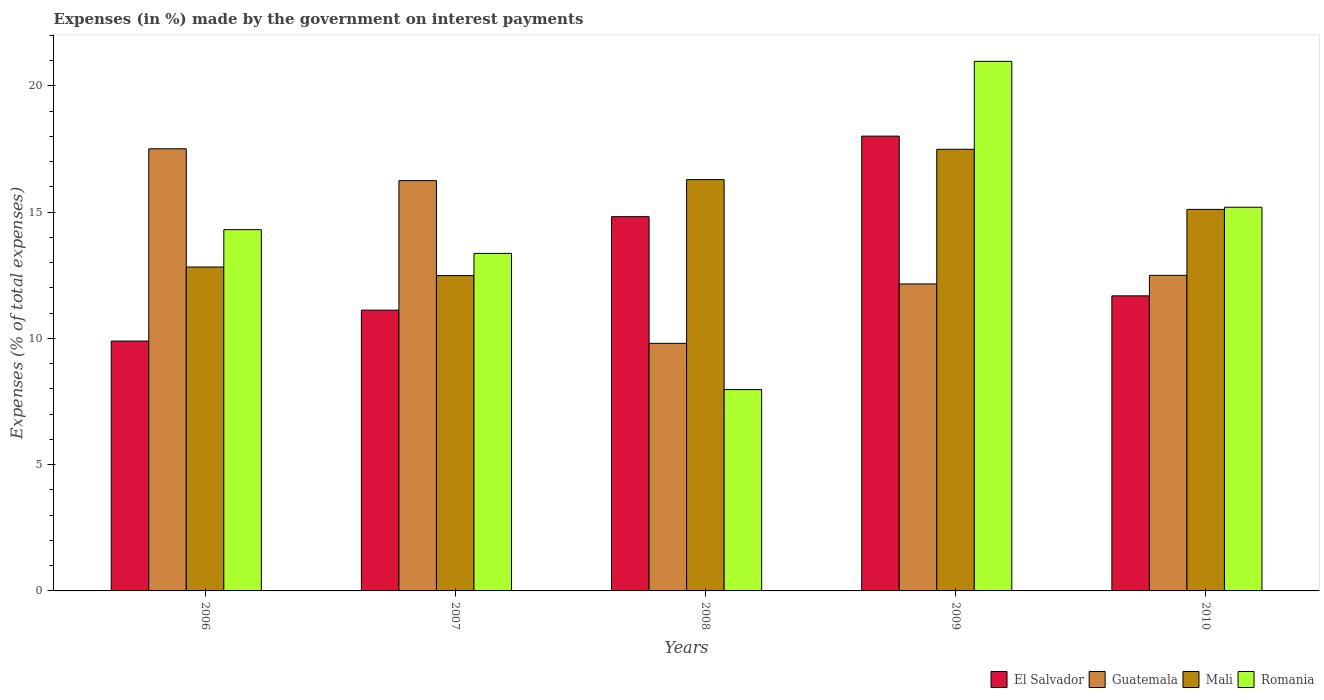Are the number of bars on each tick of the X-axis equal?
Provide a short and direct response. Yes. How many bars are there on the 2nd tick from the right?
Your answer should be compact. 4. In how many cases, is the number of bars for a given year not equal to the number of legend labels?
Give a very brief answer. 0. What is the percentage of expenses made by the government on interest payments in Mali in 2010?
Your response must be concise. 15.11. Across all years, what is the maximum percentage of expenses made by the government on interest payments in Romania?
Your response must be concise. 20.97. Across all years, what is the minimum percentage of expenses made by the government on interest payments in Mali?
Ensure brevity in your answer.  12.49. In which year was the percentage of expenses made by the government on interest payments in Guatemala maximum?
Make the answer very short. 2006. What is the total percentage of expenses made by the government on interest payments in Mali in the graph?
Give a very brief answer. 74.19. What is the difference between the percentage of expenses made by the government on interest payments in El Salvador in 2007 and that in 2009?
Offer a terse response. -6.89. What is the difference between the percentage of expenses made by the government on interest payments in Guatemala in 2007 and the percentage of expenses made by the government on interest payments in Mali in 2006?
Make the answer very short. 3.42. What is the average percentage of expenses made by the government on interest payments in El Salvador per year?
Provide a succinct answer. 13.1. In the year 2009, what is the difference between the percentage of expenses made by the government on interest payments in Guatemala and percentage of expenses made by the government on interest payments in El Salvador?
Give a very brief answer. -5.85. What is the ratio of the percentage of expenses made by the government on interest payments in Romania in 2008 to that in 2010?
Give a very brief answer. 0.52. Is the percentage of expenses made by the government on interest payments in Mali in 2006 less than that in 2010?
Provide a short and direct response. Yes. What is the difference between the highest and the second highest percentage of expenses made by the government on interest payments in Guatemala?
Offer a terse response. 1.26. What is the difference between the highest and the lowest percentage of expenses made by the government on interest payments in Mali?
Offer a very short reply. 5. Is the sum of the percentage of expenses made by the government on interest payments in El Salvador in 2007 and 2008 greater than the maximum percentage of expenses made by the government on interest payments in Romania across all years?
Provide a succinct answer. Yes. Is it the case that in every year, the sum of the percentage of expenses made by the government on interest payments in Romania and percentage of expenses made by the government on interest payments in El Salvador is greater than the sum of percentage of expenses made by the government on interest payments in Mali and percentage of expenses made by the government on interest payments in Guatemala?
Offer a terse response. No. What does the 1st bar from the left in 2010 represents?
Your response must be concise. El Salvador. What does the 4th bar from the right in 2009 represents?
Provide a short and direct response. El Salvador. Is it the case that in every year, the sum of the percentage of expenses made by the government on interest payments in Guatemala and percentage of expenses made by the government on interest payments in Mali is greater than the percentage of expenses made by the government on interest payments in Romania?
Offer a very short reply. Yes. Are all the bars in the graph horizontal?
Make the answer very short. No. How many years are there in the graph?
Your answer should be very brief. 5. What is the difference between two consecutive major ticks on the Y-axis?
Make the answer very short. 5. Does the graph contain grids?
Provide a short and direct response. No. What is the title of the graph?
Make the answer very short. Expenses (in %) made by the government on interest payments. What is the label or title of the Y-axis?
Offer a terse response. Expenses (% of total expenses). What is the Expenses (% of total expenses) in El Salvador in 2006?
Your answer should be very brief. 9.89. What is the Expenses (% of total expenses) of Guatemala in 2006?
Make the answer very short. 17.51. What is the Expenses (% of total expenses) in Mali in 2006?
Offer a very short reply. 12.82. What is the Expenses (% of total expenses) of Romania in 2006?
Offer a terse response. 14.3. What is the Expenses (% of total expenses) of El Salvador in 2007?
Make the answer very short. 11.12. What is the Expenses (% of total expenses) of Guatemala in 2007?
Offer a terse response. 16.24. What is the Expenses (% of total expenses) of Mali in 2007?
Offer a terse response. 12.49. What is the Expenses (% of total expenses) in Romania in 2007?
Keep it short and to the point. 13.36. What is the Expenses (% of total expenses) in El Salvador in 2008?
Offer a terse response. 14.82. What is the Expenses (% of total expenses) of Guatemala in 2008?
Provide a short and direct response. 9.8. What is the Expenses (% of total expenses) of Mali in 2008?
Ensure brevity in your answer.  16.28. What is the Expenses (% of total expenses) in Romania in 2008?
Keep it short and to the point. 7.97. What is the Expenses (% of total expenses) in El Salvador in 2009?
Your response must be concise. 18.01. What is the Expenses (% of total expenses) in Guatemala in 2009?
Offer a terse response. 12.15. What is the Expenses (% of total expenses) in Mali in 2009?
Ensure brevity in your answer.  17.49. What is the Expenses (% of total expenses) of Romania in 2009?
Offer a very short reply. 20.97. What is the Expenses (% of total expenses) in El Salvador in 2010?
Offer a terse response. 11.68. What is the Expenses (% of total expenses) in Guatemala in 2010?
Keep it short and to the point. 12.5. What is the Expenses (% of total expenses) of Mali in 2010?
Make the answer very short. 15.11. What is the Expenses (% of total expenses) in Romania in 2010?
Your response must be concise. 15.19. Across all years, what is the maximum Expenses (% of total expenses) of El Salvador?
Your answer should be compact. 18.01. Across all years, what is the maximum Expenses (% of total expenses) in Guatemala?
Your response must be concise. 17.51. Across all years, what is the maximum Expenses (% of total expenses) in Mali?
Provide a short and direct response. 17.49. Across all years, what is the maximum Expenses (% of total expenses) in Romania?
Keep it short and to the point. 20.97. Across all years, what is the minimum Expenses (% of total expenses) of El Salvador?
Provide a short and direct response. 9.89. Across all years, what is the minimum Expenses (% of total expenses) of Guatemala?
Offer a terse response. 9.8. Across all years, what is the minimum Expenses (% of total expenses) of Mali?
Make the answer very short. 12.49. Across all years, what is the minimum Expenses (% of total expenses) in Romania?
Offer a terse response. 7.97. What is the total Expenses (% of total expenses) in El Salvador in the graph?
Your answer should be very brief. 65.52. What is the total Expenses (% of total expenses) of Guatemala in the graph?
Give a very brief answer. 68.2. What is the total Expenses (% of total expenses) of Mali in the graph?
Provide a succinct answer. 74.19. What is the total Expenses (% of total expenses) of Romania in the graph?
Keep it short and to the point. 71.8. What is the difference between the Expenses (% of total expenses) in El Salvador in 2006 and that in 2007?
Give a very brief answer. -1.22. What is the difference between the Expenses (% of total expenses) in Guatemala in 2006 and that in 2007?
Your response must be concise. 1.26. What is the difference between the Expenses (% of total expenses) in Mali in 2006 and that in 2007?
Provide a succinct answer. 0.34. What is the difference between the Expenses (% of total expenses) in Romania in 2006 and that in 2007?
Give a very brief answer. 0.94. What is the difference between the Expenses (% of total expenses) of El Salvador in 2006 and that in 2008?
Ensure brevity in your answer.  -4.93. What is the difference between the Expenses (% of total expenses) in Guatemala in 2006 and that in 2008?
Ensure brevity in your answer.  7.7. What is the difference between the Expenses (% of total expenses) of Mali in 2006 and that in 2008?
Keep it short and to the point. -3.46. What is the difference between the Expenses (% of total expenses) of Romania in 2006 and that in 2008?
Offer a terse response. 6.33. What is the difference between the Expenses (% of total expenses) in El Salvador in 2006 and that in 2009?
Your response must be concise. -8.11. What is the difference between the Expenses (% of total expenses) in Guatemala in 2006 and that in 2009?
Your answer should be compact. 5.35. What is the difference between the Expenses (% of total expenses) in Mali in 2006 and that in 2009?
Your answer should be compact. -4.66. What is the difference between the Expenses (% of total expenses) in Romania in 2006 and that in 2009?
Your response must be concise. -6.66. What is the difference between the Expenses (% of total expenses) of El Salvador in 2006 and that in 2010?
Make the answer very short. -1.79. What is the difference between the Expenses (% of total expenses) in Guatemala in 2006 and that in 2010?
Your response must be concise. 5.01. What is the difference between the Expenses (% of total expenses) of Mali in 2006 and that in 2010?
Provide a short and direct response. -2.28. What is the difference between the Expenses (% of total expenses) in Romania in 2006 and that in 2010?
Offer a terse response. -0.89. What is the difference between the Expenses (% of total expenses) in El Salvador in 2007 and that in 2008?
Offer a very short reply. -3.7. What is the difference between the Expenses (% of total expenses) in Guatemala in 2007 and that in 2008?
Keep it short and to the point. 6.44. What is the difference between the Expenses (% of total expenses) of Mali in 2007 and that in 2008?
Your answer should be very brief. -3.8. What is the difference between the Expenses (% of total expenses) of Romania in 2007 and that in 2008?
Make the answer very short. 5.39. What is the difference between the Expenses (% of total expenses) of El Salvador in 2007 and that in 2009?
Make the answer very short. -6.89. What is the difference between the Expenses (% of total expenses) of Guatemala in 2007 and that in 2009?
Make the answer very short. 4.09. What is the difference between the Expenses (% of total expenses) in Mali in 2007 and that in 2009?
Offer a terse response. -5. What is the difference between the Expenses (% of total expenses) in Romania in 2007 and that in 2009?
Make the answer very short. -7.6. What is the difference between the Expenses (% of total expenses) in El Salvador in 2007 and that in 2010?
Your answer should be very brief. -0.57. What is the difference between the Expenses (% of total expenses) in Guatemala in 2007 and that in 2010?
Keep it short and to the point. 3.75. What is the difference between the Expenses (% of total expenses) in Mali in 2007 and that in 2010?
Provide a short and direct response. -2.62. What is the difference between the Expenses (% of total expenses) in Romania in 2007 and that in 2010?
Provide a short and direct response. -1.83. What is the difference between the Expenses (% of total expenses) of El Salvador in 2008 and that in 2009?
Offer a very short reply. -3.19. What is the difference between the Expenses (% of total expenses) of Guatemala in 2008 and that in 2009?
Give a very brief answer. -2.35. What is the difference between the Expenses (% of total expenses) in Mali in 2008 and that in 2009?
Provide a succinct answer. -1.2. What is the difference between the Expenses (% of total expenses) of Romania in 2008 and that in 2009?
Your response must be concise. -13. What is the difference between the Expenses (% of total expenses) in El Salvador in 2008 and that in 2010?
Give a very brief answer. 3.14. What is the difference between the Expenses (% of total expenses) of Guatemala in 2008 and that in 2010?
Make the answer very short. -2.69. What is the difference between the Expenses (% of total expenses) in Mali in 2008 and that in 2010?
Provide a short and direct response. 1.18. What is the difference between the Expenses (% of total expenses) of Romania in 2008 and that in 2010?
Your answer should be very brief. -7.22. What is the difference between the Expenses (% of total expenses) of El Salvador in 2009 and that in 2010?
Your answer should be compact. 6.32. What is the difference between the Expenses (% of total expenses) of Guatemala in 2009 and that in 2010?
Your answer should be very brief. -0.34. What is the difference between the Expenses (% of total expenses) in Mali in 2009 and that in 2010?
Offer a very short reply. 2.38. What is the difference between the Expenses (% of total expenses) in Romania in 2009 and that in 2010?
Keep it short and to the point. 5.78. What is the difference between the Expenses (% of total expenses) in El Salvador in 2006 and the Expenses (% of total expenses) in Guatemala in 2007?
Make the answer very short. -6.35. What is the difference between the Expenses (% of total expenses) in El Salvador in 2006 and the Expenses (% of total expenses) in Mali in 2007?
Keep it short and to the point. -2.59. What is the difference between the Expenses (% of total expenses) of El Salvador in 2006 and the Expenses (% of total expenses) of Romania in 2007?
Offer a very short reply. -3.47. What is the difference between the Expenses (% of total expenses) of Guatemala in 2006 and the Expenses (% of total expenses) of Mali in 2007?
Keep it short and to the point. 5.02. What is the difference between the Expenses (% of total expenses) in Guatemala in 2006 and the Expenses (% of total expenses) in Romania in 2007?
Your response must be concise. 4.14. What is the difference between the Expenses (% of total expenses) of Mali in 2006 and the Expenses (% of total expenses) of Romania in 2007?
Offer a very short reply. -0.54. What is the difference between the Expenses (% of total expenses) in El Salvador in 2006 and the Expenses (% of total expenses) in Guatemala in 2008?
Ensure brevity in your answer.  0.09. What is the difference between the Expenses (% of total expenses) in El Salvador in 2006 and the Expenses (% of total expenses) in Mali in 2008?
Make the answer very short. -6.39. What is the difference between the Expenses (% of total expenses) of El Salvador in 2006 and the Expenses (% of total expenses) of Romania in 2008?
Keep it short and to the point. 1.92. What is the difference between the Expenses (% of total expenses) of Guatemala in 2006 and the Expenses (% of total expenses) of Mali in 2008?
Keep it short and to the point. 1.22. What is the difference between the Expenses (% of total expenses) of Guatemala in 2006 and the Expenses (% of total expenses) of Romania in 2008?
Offer a terse response. 9.53. What is the difference between the Expenses (% of total expenses) of Mali in 2006 and the Expenses (% of total expenses) of Romania in 2008?
Give a very brief answer. 4.85. What is the difference between the Expenses (% of total expenses) in El Salvador in 2006 and the Expenses (% of total expenses) in Guatemala in 2009?
Your answer should be compact. -2.26. What is the difference between the Expenses (% of total expenses) of El Salvador in 2006 and the Expenses (% of total expenses) of Mali in 2009?
Offer a terse response. -7.59. What is the difference between the Expenses (% of total expenses) in El Salvador in 2006 and the Expenses (% of total expenses) in Romania in 2009?
Make the answer very short. -11.07. What is the difference between the Expenses (% of total expenses) of Guatemala in 2006 and the Expenses (% of total expenses) of Mali in 2009?
Your answer should be compact. 0.02. What is the difference between the Expenses (% of total expenses) in Guatemala in 2006 and the Expenses (% of total expenses) in Romania in 2009?
Provide a short and direct response. -3.46. What is the difference between the Expenses (% of total expenses) of Mali in 2006 and the Expenses (% of total expenses) of Romania in 2009?
Offer a terse response. -8.14. What is the difference between the Expenses (% of total expenses) of El Salvador in 2006 and the Expenses (% of total expenses) of Guatemala in 2010?
Give a very brief answer. -2.6. What is the difference between the Expenses (% of total expenses) in El Salvador in 2006 and the Expenses (% of total expenses) in Mali in 2010?
Provide a succinct answer. -5.21. What is the difference between the Expenses (% of total expenses) of El Salvador in 2006 and the Expenses (% of total expenses) of Romania in 2010?
Provide a succinct answer. -5.3. What is the difference between the Expenses (% of total expenses) of Guatemala in 2006 and the Expenses (% of total expenses) of Mali in 2010?
Your answer should be compact. 2.4. What is the difference between the Expenses (% of total expenses) of Guatemala in 2006 and the Expenses (% of total expenses) of Romania in 2010?
Provide a succinct answer. 2.31. What is the difference between the Expenses (% of total expenses) of Mali in 2006 and the Expenses (% of total expenses) of Romania in 2010?
Ensure brevity in your answer.  -2.37. What is the difference between the Expenses (% of total expenses) of El Salvador in 2007 and the Expenses (% of total expenses) of Guatemala in 2008?
Your answer should be compact. 1.32. What is the difference between the Expenses (% of total expenses) of El Salvador in 2007 and the Expenses (% of total expenses) of Mali in 2008?
Your response must be concise. -5.17. What is the difference between the Expenses (% of total expenses) in El Salvador in 2007 and the Expenses (% of total expenses) in Romania in 2008?
Your response must be concise. 3.15. What is the difference between the Expenses (% of total expenses) in Guatemala in 2007 and the Expenses (% of total expenses) in Mali in 2008?
Provide a succinct answer. -0.04. What is the difference between the Expenses (% of total expenses) in Guatemala in 2007 and the Expenses (% of total expenses) in Romania in 2008?
Provide a succinct answer. 8.27. What is the difference between the Expenses (% of total expenses) of Mali in 2007 and the Expenses (% of total expenses) of Romania in 2008?
Offer a very short reply. 4.51. What is the difference between the Expenses (% of total expenses) in El Salvador in 2007 and the Expenses (% of total expenses) in Guatemala in 2009?
Ensure brevity in your answer.  -1.04. What is the difference between the Expenses (% of total expenses) in El Salvador in 2007 and the Expenses (% of total expenses) in Mali in 2009?
Provide a succinct answer. -6.37. What is the difference between the Expenses (% of total expenses) of El Salvador in 2007 and the Expenses (% of total expenses) of Romania in 2009?
Offer a terse response. -9.85. What is the difference between the Expenses (% of total expenses) in Guatemala in 2007 and the Expenses (% of total expenses) in Mali in 2009?
Give a very brief answer. -1.24. What is the difference between the Expenses (% of total expenses) in Guatemala in 2007 and the Expenses (% of total expenses) in Romania in 2009?
Ensure brevity in your answer.  -4.72. What is the difference between the Expenses (% of total expenses) of Mali in 2007 and the Expenses (% of total expenses) of Romania in 2009?
Your response must be concise. -8.48. What is the difference between the Expenses (% of total expenses) of El Salvador in 2007 and the Expenses (% of total expenses) of Guatemala in 2010?
Your answer should be very brief. -1.38. What is the difference between the Expenses (% of total expenses) of El Salvador in 2007 and the Expenses (% of total expenses) of Mali in 2010?
Offer a very short reply. -3.99. What is the difference between the Expenses (% of total expenses) in El Salvador in 2007 and the Expenses (% of total expenses) in Romania in 2010?
Provide a short and direct response. -4.07. What is the difference between the Expenses (% of total expenses) of Guatemala in 2007 and the Expenses (% of total expenses) of Mali in 2010?
Your answer should be very brief. 1.14. What is the difference between the Expenses (% of total expenses) in Guatemala in 2007 and the Expenses (% of total expenses) in Romania in 2010?
Your response must be concise. 1.05. What is the difference between the Expenses (% of total expenses) in Mali in 2007 and the Expenses (% of total expenses) in Romania in 2010?
Offer a terse response. -2.71. What is the difference between the Expenses (% of total expenses) in El Salvador in 2008 and the Expenses (% of total expenses) in Guatemala in 2009?
Offer a terse response. 2.66. What is the difference between the Expenses (% of total expenses) of El Salvador in 2008 and the Expenses (% of total expenses) of Mali in 2009?
Give a very brief answer. -2.67. What is the difference between the Expenses (% of total expenses) in El Salvador in 2008 and the Expenses (% of total expenses) in Romania in 2009?
Offer a terse response. -6.15. What is the difference between the Expenses (% of total expenses) of Guatemala in 2008 and the Expenses (% of total expenses) of Mali in 2009?
Provide a short and direct response. -7.68. What is the difference between the Expenses (% of total expenses) in Guatemala in 2008 and the Expenses (% of total expenses) in Romania in 2009?
Provide a succinct answer. -11.17. What is the difference between the Expenses (% of total expenses) of Mali in 2008 and the Expenses (% of total expenses) of Romania in 2009?
Your answer should be compact. -4.68. What is the difference between the Expenses (% of total expenses) in El Salvador in 2008 and the Expenses (% of total expenses) in Guatemala in 2010?
Your answer should be very brief. 2.32. What is the difference between the Expenses (% of total expenses) in El Salvador in 2008 and the Expenses (% of total expenses) in Mali in 2010?
Your answer should be compact. -0.29. What is the difference between the Expenses (% of total expenses) of El Salvador in 2008 and the Expenses (% of total expenses) of Romania in 2010?
Provide a succinct answer. -0.37. What is the difference between the Expenses (% of total expenses) in Guatemala in 2008 and the Expenses (% of total expenses) in Mali in 2010?
Offer a terse response. -5.3. What is the difference between the Expenses (% of total expenses) in Guatemala in 2008 and the Expenses (% of total expenses) in Romania in 2010?
Keep it short and to the point. -5.39. What is the difference between the Expenses (% of total expenses) in Mali in 2008 and the Expenses (% of total expenses) in Romania in 2010?
Offer a very short reply. 1.09. What is the difference between the Expenses (% of total expenses) of El Salvador in 2009 and the Expenses (% of total expenses) of Guatemala in 2010?
Make the answer very short. 5.51. What is the difference between the Expenses (% of total expenses) in El Salvador in 2009 and the Expenses (% of total expenses) in Mali in 2010?
Keep it short and to the point. 2.9. What is the difference between the Expenses (% of total expenses) in El Salvador in 2009 and the Expenses (% of total expenses) in Romania in 2010?
Your answer should be compact. 2.82. What is the difference between the Expenses (% of total expenses) in Guatemala in 2009 and the Expenses (% of total expenses) in Mali in 2010?
Make the answer very short. -2.95. What is the difference between the Expenses (% of total expenses) in Guatemala in 2009 and the Expenses (% of total expenses) in Romania in 2010?
Your answer should be compact. -3.04. What is the difference between the Expenses (% of total expenses) in Mali in 2009 and the Expenses (% of total expenses) in Romania in 2010?
Provide a short and direct response. 2.3. What is the average Expenses (% of total expenses) of El Salvador per year?
Your answer should be compact. 13.1. What is the average Expenses (% of total expenses) in Guatemala per year?
Ensure brevity in your answer.  13.64. What is the average Expenses (% of total expenses) of Mali per year?
Provide a succinct answer. 14.84. What is the average Expenses (% of total expenses) of Romania per year?
Make the answer very short. 14.36. In the year 2006, what is the difference between the Expenses (% of total expenses) in El Salvador and Expenses (% of total expenses) in Guatemala?
Make the answer very short. -7.61. In the year 2006, what is the difference between the Expenses (% of total expenses) in El Salvador and Expenses (% of total expenses) in Mali?
Offer a terse response. -2.93. In the year 2006, what is the difference between the Expenses (% of total expenses) of El Salvador and Expenses (% of total expenses) of Romania?
Ensure brevity in your answer.  -4.41. In the year 2006, what is the difference between the Expenses (% of total expenses) of Guatemala and Expenses (% of total expenses) of Mali?
Ensure brevity in your answer.  4.68. In the year 2006, what is the difference between the Expenses (% of total expenses) of Guatemala and Expenses (% of total expenses) of Romania?
Offer a terse response. 3.2. In the year 2006, what is the difference between the Expenses (% of total expenses) in Mali and Expenses (% of total expenses) in Romania?
Offer a terse response. -1.48. In the year 2007, what is the difference between the Expenses (% of total expenses) in El Salvador and Expenses (% of total expenses) in Guatemala?
Give a very brief answer. -5.13. In the year 2007, what is the difference between the Expenses (% of total expenses) in El Salvador and Expenses (% of total expenses) in Mali?
Keep it short and to the point. -1.37. In the year 2007, what is the difference between the Expenses (% of total expenses) of El Salvador and Expenses (% of total expenses) of Romania?
Your response must be concise. -2.25. In the year 2007, what is the difference between the Expenses (% of total expenses) in Guatemala and Expenses (% of total expenses) in Mali?
Offer a terse response. 3.76. In the year 2007, what is the difference between the Expenses (% of total expenses) of Guatemala and Expenses (% of total expenses) of Romania?
Offer a terse response. 2.88. In the year 2007, what is the difference between the Expenses (% of total expenses) of Mali and Expenses (% of total expenses) of Romania?
Ensure brevity in your answer.  -0.88. In the year 2008, what is the difference between the Expenses (% of total expenses) in El Salvador and Expenses (% of total expenses) in Guatemala?
Give a very brief answer. 5.02. In the year 2008, what is the difference between the Expenses (% of total expenses) of El Salvador and Expenses (% of total expenses) of Mali?
Offer a very short reply. -1.47. In the year 2008, what is the difference between the Expenses (% of total expenses) of El Salvador and Expenses (% of total expenses) of Romania?
Your answer should be compact. 6.85. In the year 2008, what is the difference between the Expenses (% of total expenses) in Guatemala and Expenses (% of total expenses) in Mali?
Make the answer very short. -6.48. In the year 2008, what is the difference between the Expenses (% of total expenses) of Guatemala and Expenses (% of total expenses) of Romania?
Your answer should be compact. 1.83. In the year 2008, what is the difference between the Expenses (% of total expenses) of Mali and Expenses (% of total expenses) of Romania?
Your answer should be very brief. 8.31. In the year 2009, what is the difference between the Expenses (% of total expenses) of El Salvador and Expenses (% of total expenses) of Guatemala?
Offer a very short reply. 5.85. In the year 2009, what is the difference between the Expenses (% of total expenses) of El Salvador and Expenses (% of total expenses) of Mali?
Provide a succinct answer. 0.52. In the year 2009, what is the difference between the Expenses (% of total expenses) of El Salvador and Expenses (% of total expenses) of Romania?
Your answer should be very brief. -2.96. In the year 2009, what is the difference between the Expenses (% of total expenses) in Guatemala and Expenses (% of total expenses) in Mali?
Offer a terse response. -5.33. In the year 2009, what is the difference between the Expenses (% of total expenses) of Guatemala and Expenses (% of total expenses) of Romania?
Your response must be concise. -8.81. In the year 2009, what is the difference between the Expenses (% of total expenses) of Mali and Expenses (% of total expenses) of Romania?
Offer a terse response. -3.48. In the year 2010, what is the difference between the Expenses (% of total expenses) in El Salvador and Expenses (% of total expenses) in Guatemala?
Give a very brief answer. -0.81. In the year 2010, what is the difference between the Expenses (% of total expenses) of El Salvador and Expenses (% of total expenses) of Mali?
Give a very brief answer. -3.42. In the year 2010, what is the difference between the Expenses (% of total expenses) in El Salvador and Expenses (% of total expenses) in Romania?
Offer a terse response. -3.51. In the year 2010, what is the difference between the Expenses (% of total expenses) in Guatemala and Expenses (% of total expenses) in Mali?
Provide a short and direct response. -2.61. In the year 2010, what is the difference between the Expenses (% of total expenses) in Guatemala and Expenses (% of total expenses) in Romania?
Provide a short and direct response. -2.7. In the year 2010, what is the difference between the Expenses (% of total expenses) in Mali and Expenses (% of total expenses) in Romania?
Provide a succinct answer. -0.09. What is the ratio of the Expenses (% of total expenses) in El Salvador in 2006 to that in 2007?
Provide a succinct answer. 0.89. What is the ratio of the Expenses (% of total expenses) in Guatemala in 2006 to that in 2007?
Provide a short and direct response. 1.08. What is the ratio of the Expenses (% of total expenses) in Mali in 2006 to that in 2007?
Provide a succinct answer. 1.03. What is the ratio of the Expenses (% of total expenses) of Romania in 2006 to that in 2007?
Your answer should be very brief. 1.07. What is the ratio of the Expenses (% of total expenses) in El Salvador in 2006 to that in 2008?
Give a very brief answer. 0.67. What is the ratio of the Expenses (% of total expenses) of Guatemala in 2006 to that in 2008?
Provide a succinct answer. 1.79. What is the ratio of the Expenses (% of total expenses) in Mali in 2006 to that in 2008?
Ensure brevity in your answer.  0.79. What is the ratio of the Expenses (% of total expenses) of Romania in 2006 to that in 2008?
Give a very brief answer. 1.79. What is the ratio of the Expenses (% of total expenses) in El Salvador in 2006 to that in 2009?
Offer a terse response. 0.55. What is the ratio of the Expenses (% of total expenses) of Guatemala in 2006 to that in 2009?
Keep it short and to the point. 1.44. What is the ratio of the Expenses (% of total expenses) of Mali in 2006 to that in 2009?
Provide a succinct answer. 0.73. What is the ratio of the Expenses (% of total expenses) of Romania in 2006 to that in 2009?
Your answer should be compact. 0.68. What is the ratio of the Expenses (% of total expenses) of El Salvador in 2006 to that in 2010?
Offer a terse response. 0.85. What is the ratio of the Expenses (% of total expenses) in Guatemala in 2006 to that in 2010?
Your answer should be compact. 1.4. What is the ratio of the Expenses (% of total expenses) in Mali in 2006 to that in 2010?
Your answer should be compact. 0.85. What is the ratio of the Expenses (% of total expenses) in Romania in 2006 to that in 2010?
Offer a very short reply. 0.94. What is the ratio of the Expenses (% of total expenses) in El Salvador in 2007 to that in 2008?
Your answer should be compact. 0.75. What is the ratio of the Expenses (% of total expenses) in Guatemala in 2007 to that in 2008?
Give a very brief answer. 1.66. What is the ratio of the Expenses (% of total expenses) of Mali in 2007 to that in 2008?
Provide a short and direct response. 0.77. What is the ratio of the Expenses (% of total expenses) in Romania in 2007 to that in 2008?
Keep it short and to the point. 1.68. What is the ratio of the Expenses (% of total expenses) in El Salvador in 2007 to that in 2009?
Provide a short and direct response. 0.62. What is the ratio of the Expenses (% of total expenses) of Guatemala in 2007 to that in 2009?
Your answer should be very brief. 1.34. What is the ratio of the Expenses (% of total expenses) in Mali in 2007 to that in 2009?
Ensure brevity in your answer.  0.71. What is the ratio of the Expenses (% of total expenses) of Romania in 2007 to that in 2009?
Make the answer very short. 0.64. What is the ratio of the Expenses (% of total expenses) of El Salvador in 2007 to that in 2010?
Make the answer very short. 0.95. What is the ratio of the Expenses (% of total expenses) in Guatemala in 2007 to that in 2010?
Keep it short and to the point. 1.3. What is the ratio of the Expenses (% of total expenses) in Mali in 2007 to that in 2010?
Provide a succinct answer. 0.83. What is the ratio of the Expenses (% of total expenses) in Romania in 2007 to that in 2010?
Keep it short and to the point. 0.88. What is the ratio of the Expenses (% of total expenses) of El Salvador in 2008 to that in 2009?
Offer a terse response. 0.82. What is the ratio of the Expenses (% of total expenses) in Guatemala in 2008 to that in 2009?
Offer a very short reply. 0.81. What is the ratio of the Expenses (% of total expenses) in Mali in 2008 to that in 2009?
Provide a short and direct response. 0.93. What is the ratio of the Expenses (% of total expenses) of Romania in 2008 to that in 2009?
Your answer should be compact. 0.38. What is the ratio of the Expenses (% of total expenses) in El Salvador in 2008 to that in 2010?
Offer a very short reply. 1.27. What is the ratio of the Expenses (% of total expenses) in Guatemala in 2008 to that in 2010?
Ensure brevity in your answer.  0.78. What is the ratio of the Expenses (% of total expenses) in Mali in 2008 to that in 2010?
Provide a short and direct response. 1.08. What is the ratio of the Expenses (% of total expenses) in Romania in 2008 to that in 2010?
Offer a terse response. 0.52. What is the ratio of the Expenses (% of total expenses) in El Salvador in 2009 to that in 2010?
Provide a short and direct response. 1.54. What is the ratio of the Expenses (% of total expenses) of Guatemala in 2009 to that in 2010?
Your response must be concise. 0.97. What is the ratio of the Expenses (% of total expenses) in Mali in 2009 to that in 2010?
Provide a short and direct response. 1.16. What is the ratio of the Expenses (% of total expenses) of Romania in 2009 to that in 2010?
Offer a terse response. 1.38. What is the difference between the highest and the second highest Expenses (% of total expenses) in El Salvador?
Your answer should be very brief. 3.19. What is the difference between the highest and the second highest Expenses (% of total expenses) in Guatemala?
Your response must be concise. 1.26. What is the difference between the highest and the second highest Expenses (% of total expenses) of Mali?
Your answer should be compact. 1.2. What is the difference between the highest and the second highest Expenses (% of total expenses) of Romania?
Provide a succinct answer. 5.78. What is the difference between the highest and the lowest Expenses (% of total expenses) of El Salvador?
Offer a terse response. 8.11. What is the difference between the highest and the lowest Expenses (% of total expenses) of Guatemala?
Your answer should be very brief. 7.7. What is the difference between the highest and the lowest Expenses (% of total expenses) of Mali?
Keep it short and to the point. 5. What is the difference between the highest and the lowest Expenses (% of total expenses) of Romania?
Provide a short and direct response. 13. 